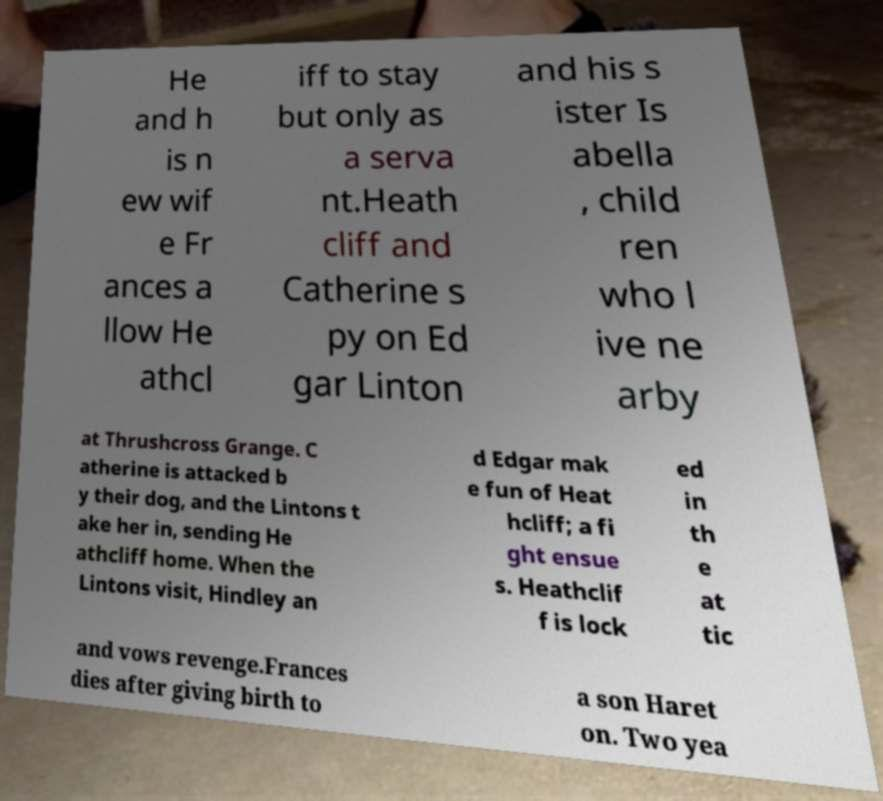Can you read and provide the text displayed in the image?This photo seems to have some interesting text. Can you extract and type it out for me? He and h is n ew wif e Fr ances a llow He athcl iff to stay but only as a serva nt.Heath cliff and Catherine s py on Ed gar Linton and his s ister Is abella , child ren who l ive ne arby at Thrushcross Grange. C atherine is attacked b y their dog, and the Lintons t ake her in, sending He athcliff home. When the Lintons visit, Hindley an d Edgar mak e fun of Heat hcliff; a fi ght ensue s. Heathclif f is lock ed in th e at tic and vows revenge.Frances dies after giving birth to a son Haret on. Two yea 